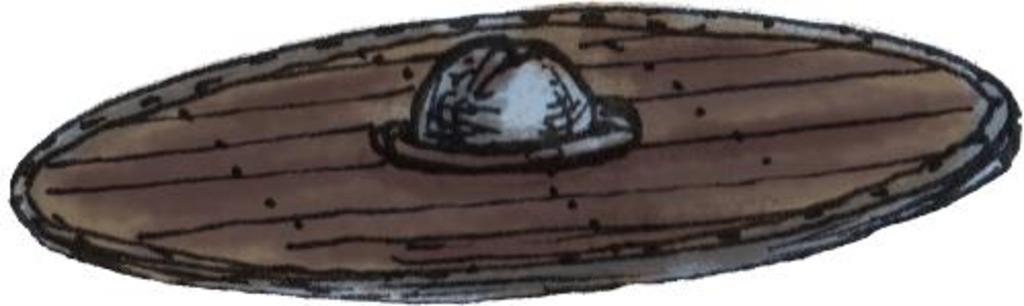Can you describe this image briefly? In this picture, we can see a poster of an art. 